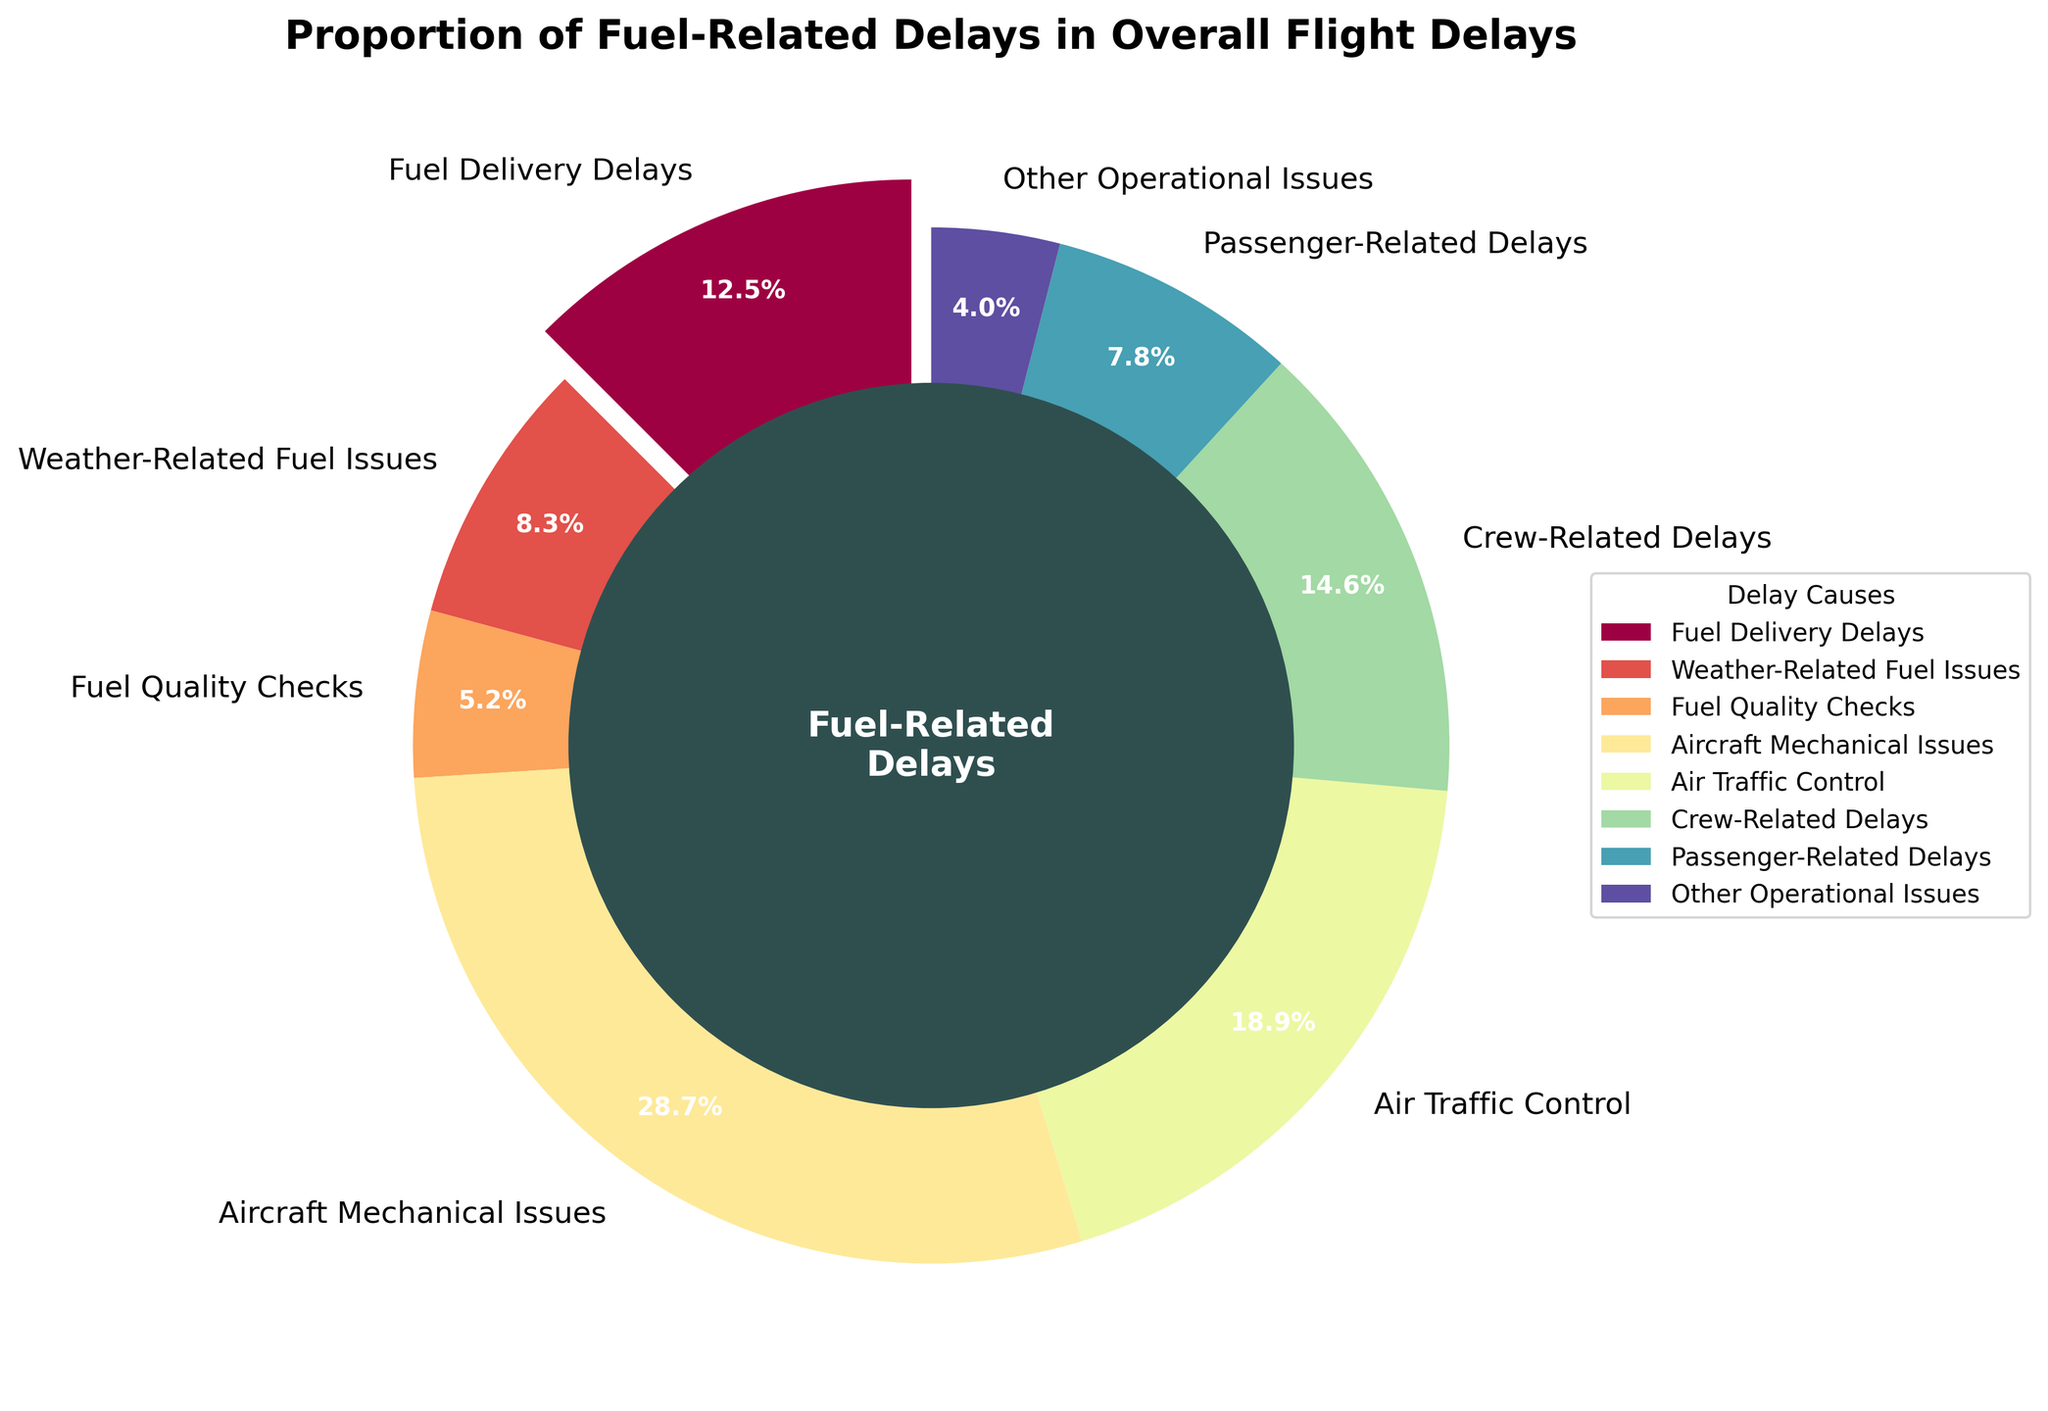Which category has the highest proportion of delays? The largest segment in the pie chart corresponds to Aircraft Mechanical Issues, which has the highest percentage.
Answer: Aircraft Mechanical Issues What is the combined percentage of all fuel-related delays? Add up the percentages for Fuel Delivery Delays (12.5%), Weather-Related Fuel Issues (8.3%), and Fuel Quality Checks (5.2%). 12.5 + 8.3 + 5.2 = 26.0%
Answer: 26.0% How much larger is the percentage of Aircraft Mechanical Issues compared to Crew-Related Delays? Subtract the percentage of Crew-Related Delays from Aircraft Mechanical Issues: 28.7% - 14.6% = 14.1%
Answer: 14.1% Which delay category has the smallest slice in the pie chart? The smallest slice in the pie chart corresponds to Other Operational Issues, which has a percentage of 4.0%.
Answer: Other Operational Issues Is the combined percentage of Weather-Related Fuel Issues and Fuel Quality Checks greater than the percentage of Crew-Related Delays? Add the percentages of Weather-Related Fuel Issues (8.3%) and Fuel Quality Checks (5.2%) and compare with Crew-Related Delays: 8.3 + 5.2 = 13.5, which is less than 14.6.
Answer: No Which delay causes have percentages that fall below 10%? Identify categories with percentages below 10%: Weather-Related Fuel Issues (8.3%), Fuel Quality Checks (5.2%), Passenger-Related Delays (7.8%), and Other Operational Issues (4.0%).
Answer: Weather-Related Fuel Issues, Fuel Quality Checks, Passenger-Related Delays, Other Operational Issues By how much does the percentage of Air Traffic Control delays exceed Passenger-Related Delays? Subtract the percentage of Passenger-Related Delays from Air Traffic Control delays: 18.9% - 7.8% = 11.1%
Answer: 11.1% What is the total percentage of non-fuel-related delays? Add up the percentages for Aircraft Mechanical Issues (28.7%), Air Traffic Control (18.9%), Crew-Related Delays (14.6%), Passenger-Related Delays (7.8%), and Other Operational Issues (4.0%). 28.7 + 18.9 + 14.6 + 7.8 + 4.0 = 74.0%
Answer: 74.0% How many fuel-related delay categories are represented in the pie chart? Count distinct categories pertaining to fuel-related delays: Fuel Delivery Delays, Weather-Related Fuel Issues, and Fuel Quality Checks.
Answer: 3 